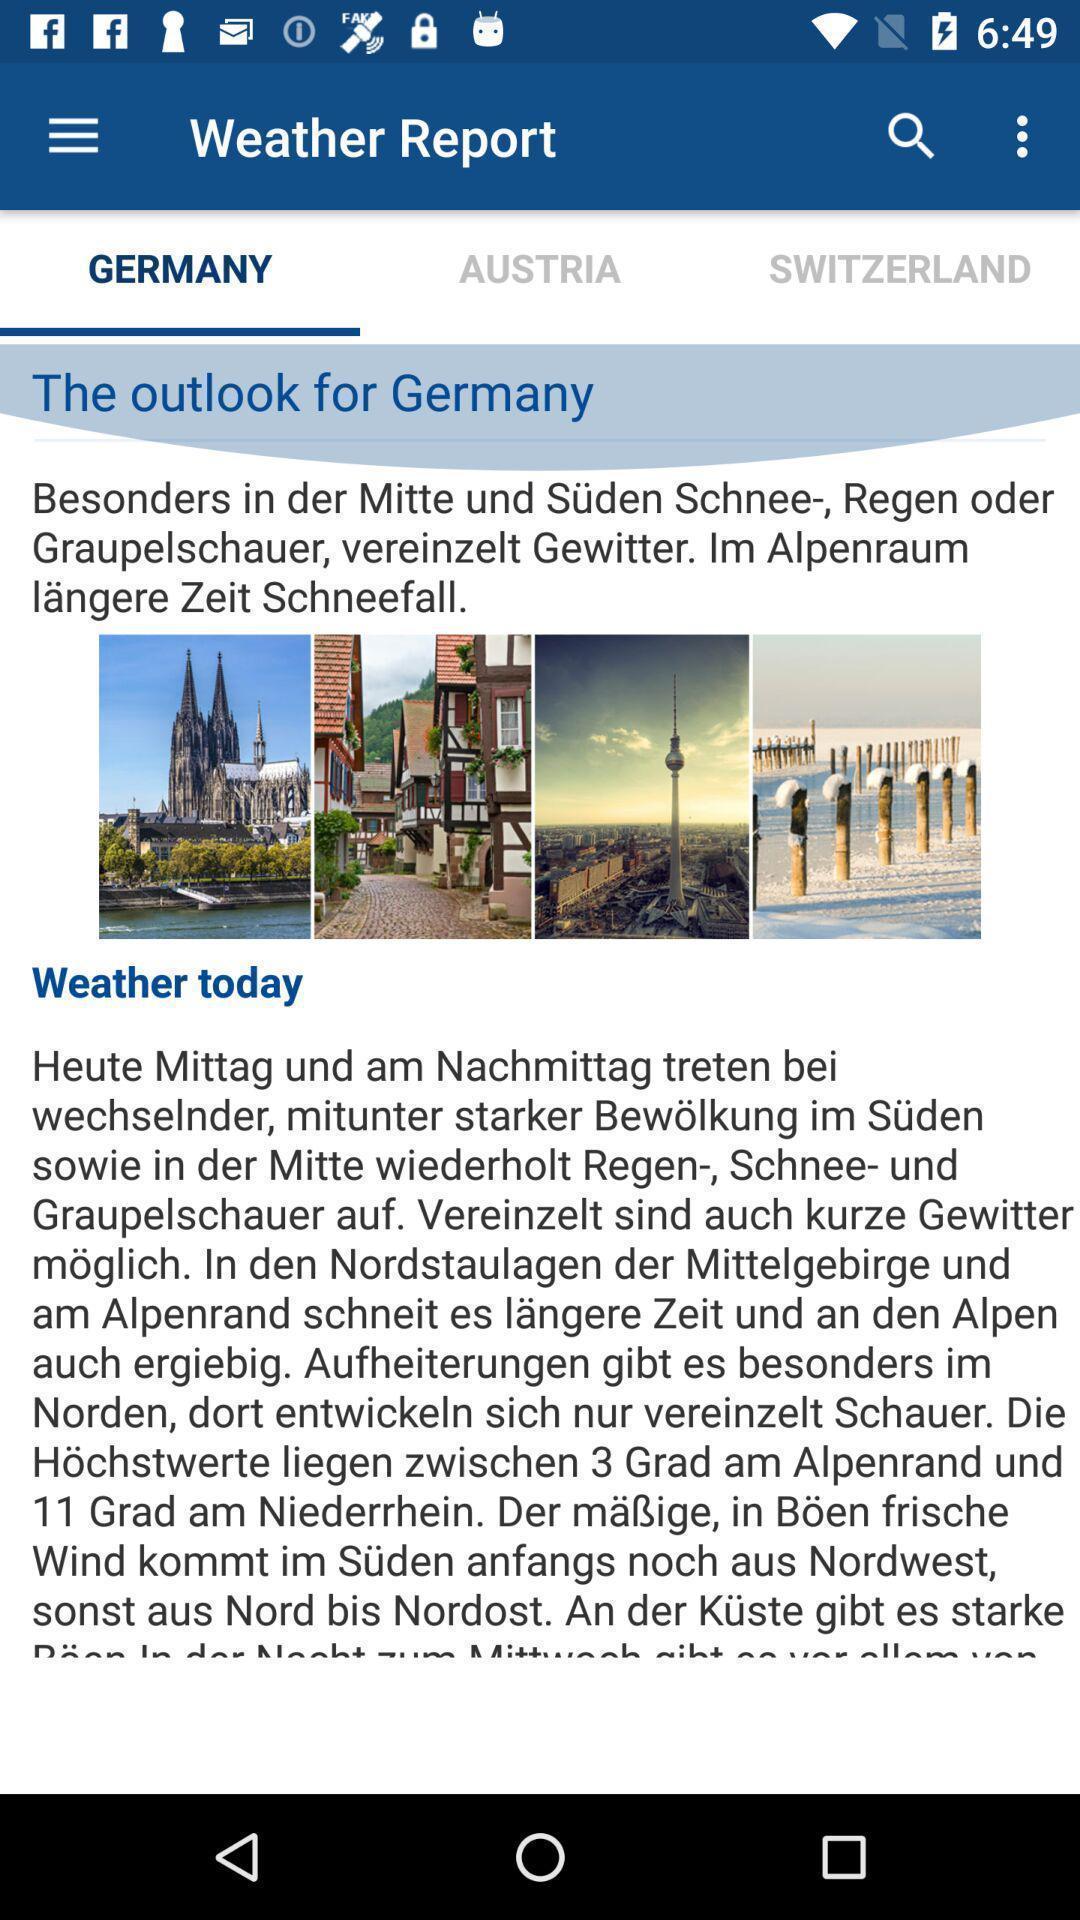Describe this image in words. Page displaying weather forecasting. 